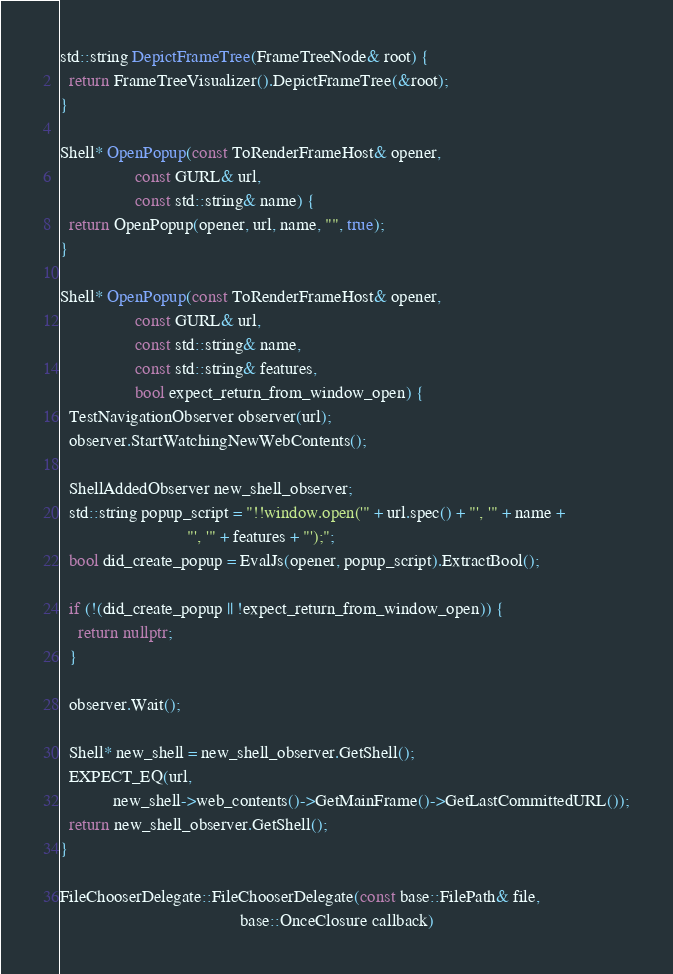Convert code to text. <code><loc_0><loc_0><loc_500><loc_500><_C++_>std::string DepictFrameTree(FrameTreeNode& root) {
  return FrameTreeVisualizer().DepictFrameTree(&root);
}

Shell* OpenPopup(const ToRenderFrameHost& opener,
                 const GURL& url,
                 const std::string& name) {
  return OpenPopup(opener, url, name, "", true);
}

Shell* OpenPopup(const ToRenderFrameHost& opener,
                 const GURL& url,
                 const std::string& name,
                 const std::string& features,
                 bool expect_return_from_window_open) {
  TestNavigationObserver observer(url);
  observer.StartWatchingNewWebContents();

  ShellAddedObserver new_shell_observer;
  std::string popup_script = "!!window.open('" + url.spec() + "', '" + name +
                             "', '" + features + "');";
  bool did_create_popup = EvalJs(opener, popup_script).ExtractBool();

  if (!(did_create_popup || !expect_return_from_window_open)) {
    return nullptr;
  }

  observer.Wait();

  Shell* new_shell = new_shell_observer.GetShell();
  EXPECT_EQ(url,
            new_shell->web_contents()->GetMainFrame()->GetLastCommittedURL());
  return new_shell_observer.GetShell();
}

FileChooserDelegate::FileChooserDelegate(const base::FilePath& file,
                                         base::OnceClosure callback)</code> 